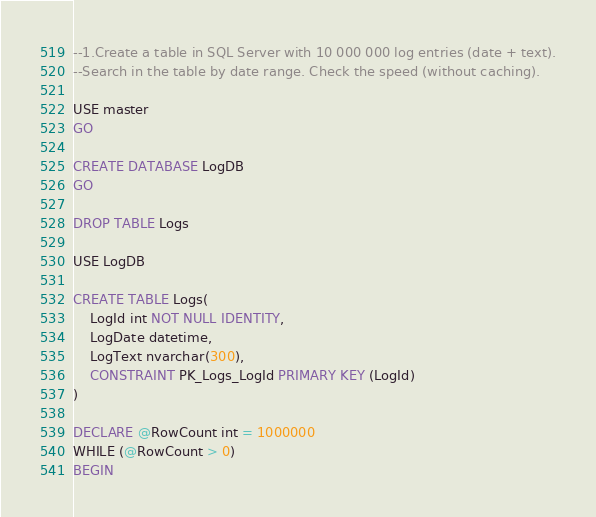<code> <loc_0><loc_0><loc_500><loc_500><_SQL_>--1.Create a table in SQL Server with 10 000 000 log entries (date + text).
--Search in the table by date range. Check the speed (without caching).

USE master
GO

CREATE DATABASE LogDB
GO

DROP TABLE Logs

USE LogDB

CREATE TABLE Logs(
	LogId int NOT NULL IDENTITY,
	LogDate datetime,
	LogText nvarchar(300),
	CONSTRAINT PK_Logs_LogId PRIMARY KEY (LogId)
)

DECLARE @RowCount int = 1000000
WHILE (@RowCount > 0)
BEGIN</code> 